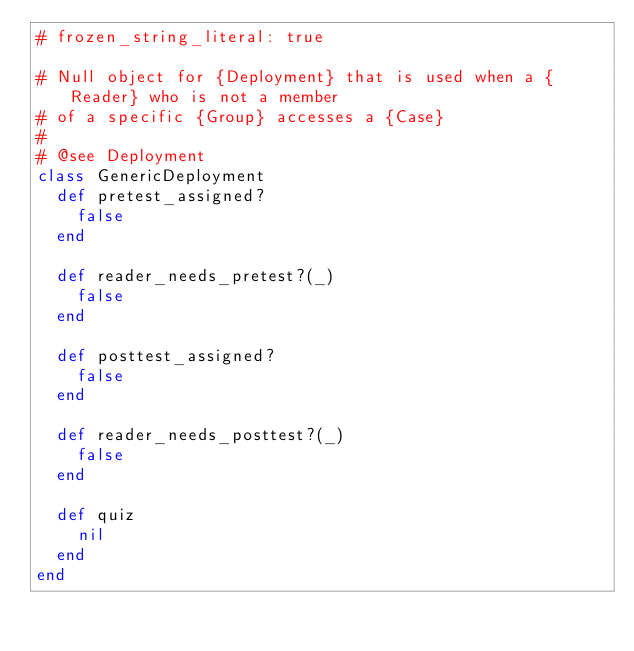<code> <loc_0><loc_0><loc_500><loc_500><_Ruby_># frozen_string_literal: true

# Null object for {Deployment} that is used when a {Reader} who is not a member
# of a specific {Group} accesses a {Case}
#
# @see Deployment
class GenericDeployment
  def pretest_assigned?
    false
  end

  def reader_needs_pretest?(_)
    false
  end

  def posttest_assigned?
    false
  end

  def reader_needs_posttest?(_)
    false
  end

  def quiz
    nil
  end
end
</code> 